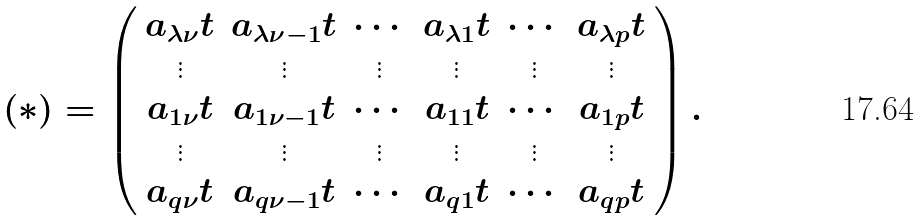Convert formula to latex. <formula><loc_0><loc_0><loc_500><loc_500>( * ) = \left ( \begin{array} { c c c c c c c c l l l l l l l l } a _ { \lambda \nu } t & a _ { \lambda \nu - 1 } t & \cdots & a _ { \lambda 1 } t & \cdots & a _ { \lambda p } t \\ \vdots & \vdots & \vdots & \vdots & \vdots & \vdots \\ a _ { 1 \nu } t & a _ { 1 \nu - 1 } t & \cdots & a _ { 1 1 } t & \cdots & a _ { 1 p } t \\ \vdots & \vdots & \vdots & \vdots & \vdots & \vdots \\ a _ { q \nu } t & a _ { q \nu - 1 } t & \cdots & a _ { q 1 } t & \cdots & a _ { q p } t \end{array} \right ) .</formula> 